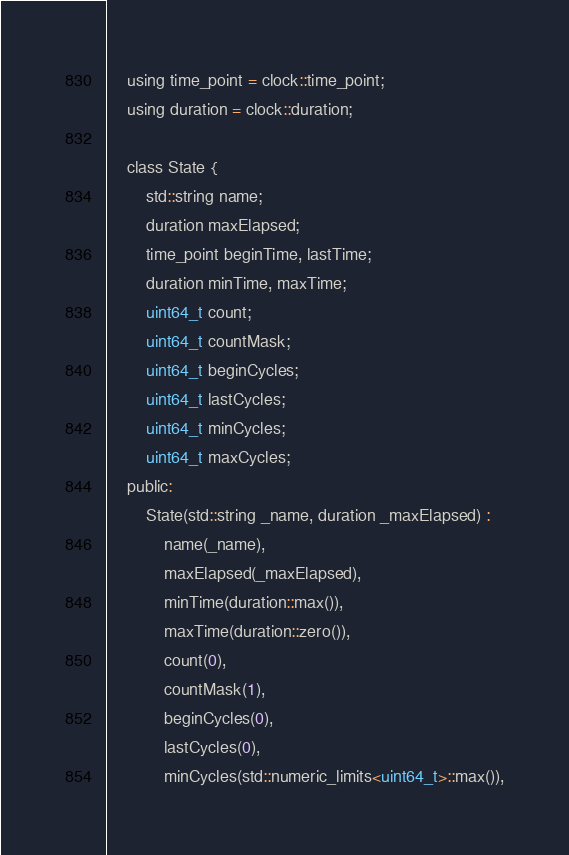<code> <loc_0><loc_0><loc_500><loc_500><_C_>    using time_point = clock::time_point;
    using duration = clock::duration;

    class State {
        std::string name;
        duration maxElapsed;
        time_point beginTime, lastTime;
        duration minTime, maxTime;
        uint64_t count;
        uint64_t countMask;
        uint64_t beginCycles;
        uint64_t lastCycles;
        uint64_t minCycles;
        uint64_t maxCycles;
    public:
        State(std::string _name, duration _maxElapsed) :
            name(_name),
            maxElapsed(_maxElapsed),
            minTime(duration::max()),
            maxTime(duration::zero()),
            count(0),
            countMask(1),
            beginCycles(0),
            lastCycles(0),
            minCycles(std::numeric_limits<uint64_t>::max()),</code> 